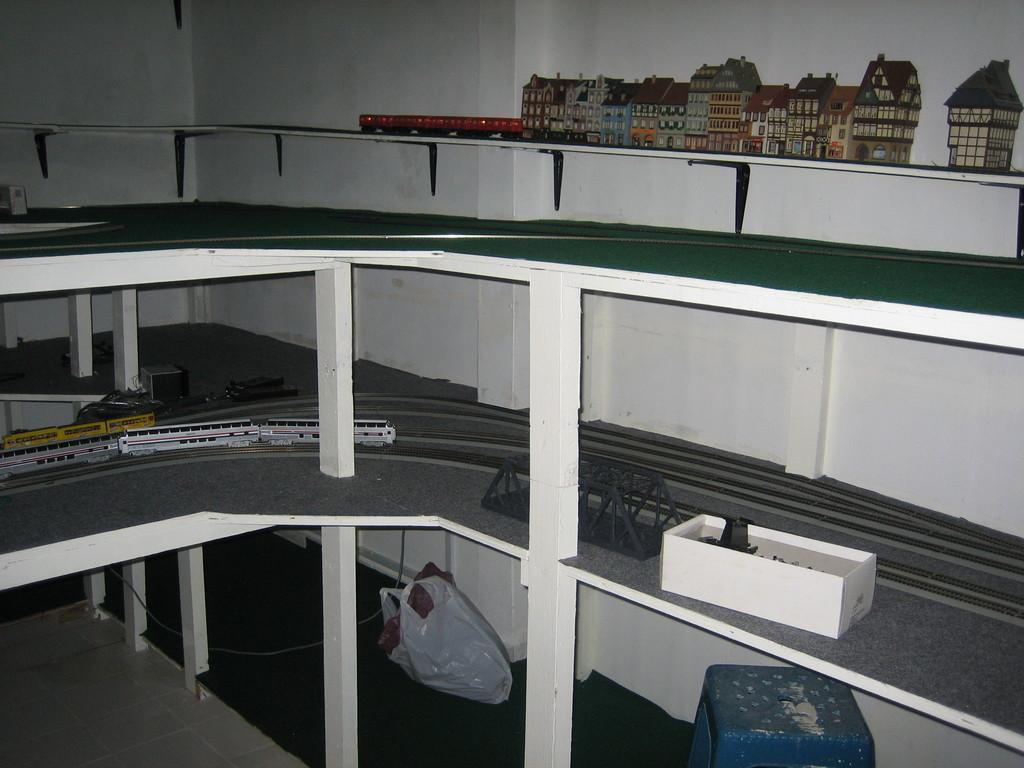What is the main subject at the top of the image? There is a miniature at the top of the image. What can be seen in the miniature? There are buildings and a railway train track in the miniature. What color is the cover at the bottom of the image? The cover at the bottom of the image is white. How many bridges are present in the miniature? There is no mention of a bridge in the image, so it cannot be determined from the facts provided. 